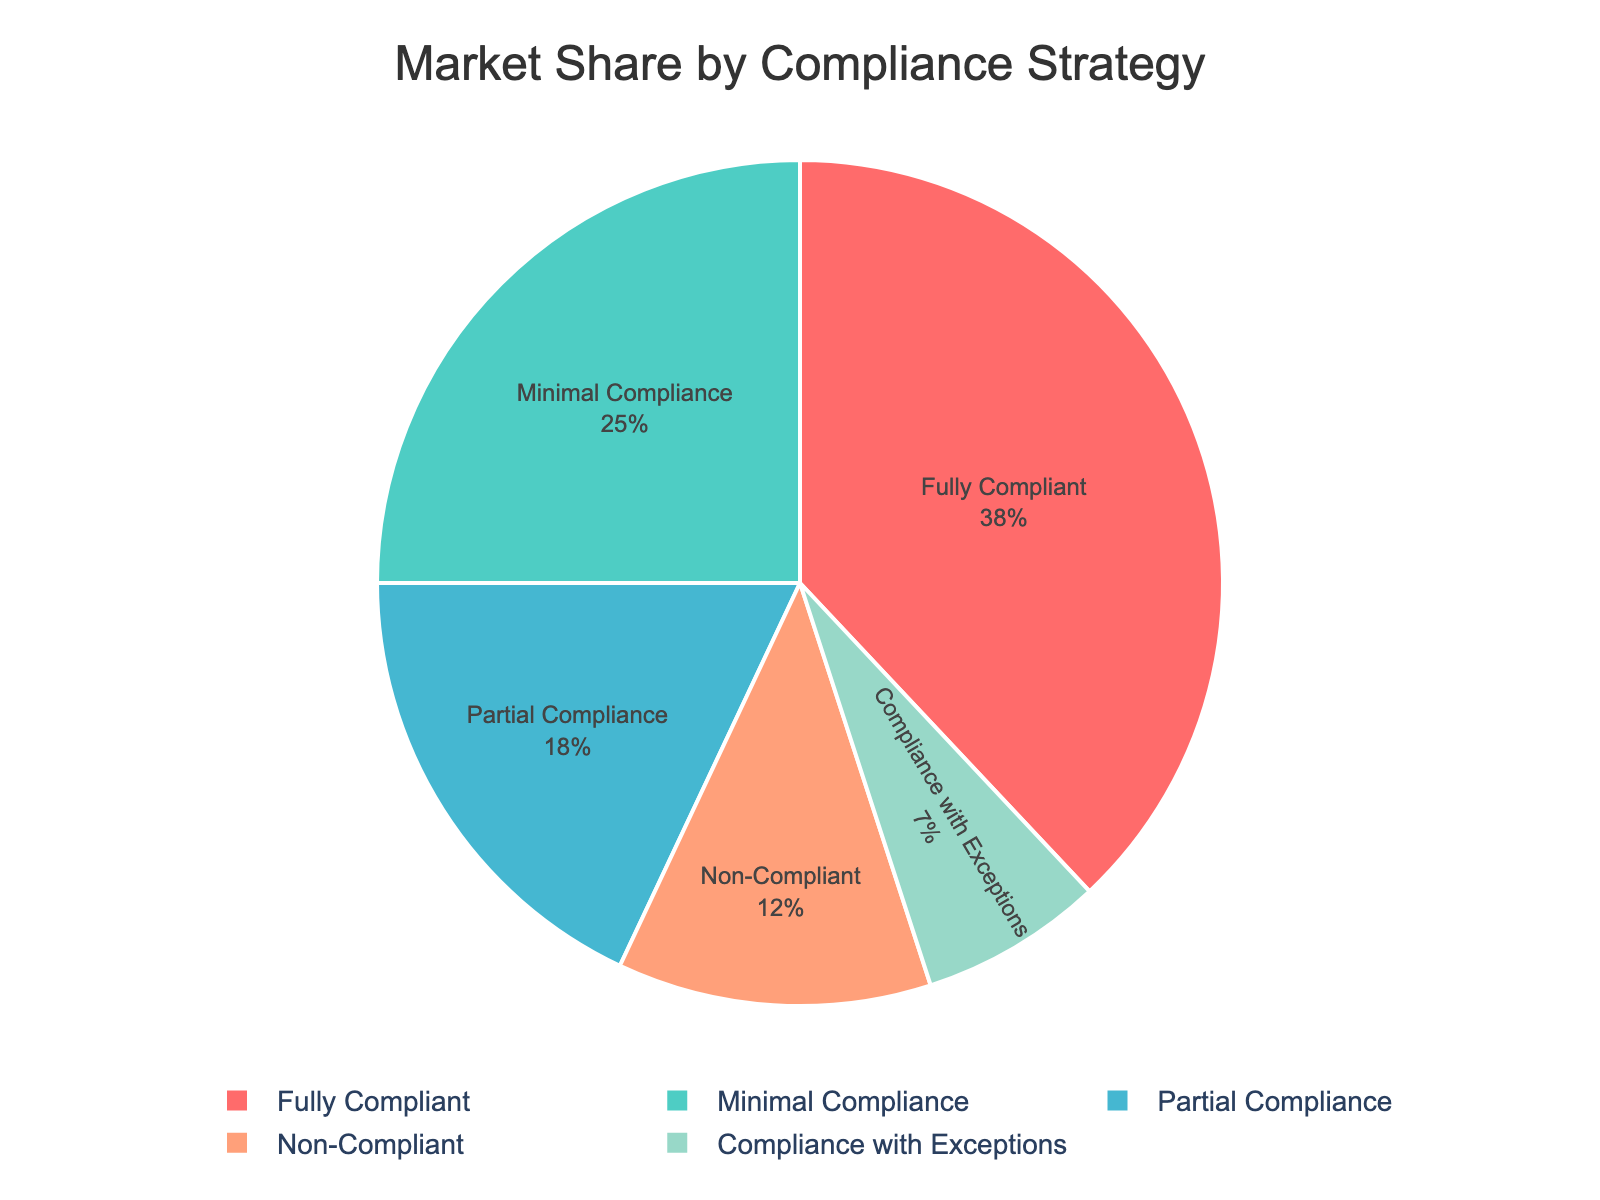What percentage of the market share is not fully compliant (i.e., minimal, non-compliant, partial, and compliance with exceptions)? To find the percentage of the market share that is not fully compliant, sum the market shares of minimal compliance (25%), non-compliant (12%), partial compliance (18%), and compliance with exceptions (7%). So, 25% + 12% + 18% + 7% = 62%.
Answer: 62% Which compliance strategy has the largest market share? Identify the segment with the highest percentage from the pie chart. The 'Fully Compliant' segment has the largest share at 38%.
Answer: Fully Compliant How does the market share of minimal compliance compare to that of partial compliance? Compare the percentages directly from the pie chart. Minimal compliance has 25%, and partial compliance has 18%. So, minimal compliance has a larger market share.
Answer: Minimal compliance is larger What is the total market share of fully compliant and partial compliance strategies combined? Sum the market shares of fully compliant (38%) and partial compliance (18%). Thus, 38% + 18% = 56%.
Answer: 56% Which compliance strategy has the smallest market share, and what is its percentage? Look for the smallest segment in the pie chart. The 'Compliance with Exceptions' strategy has the smallest share at 7%.
Answer: Compliance with Exceptions, 7% What is the ratio of the market share of fully compliant businesses to non-compliant businesses? Determine the percentages from the chart: fully compliant is 38%, and non-compliant is 12%. The ratio is 38/12, which simplifies to about 3.17.
Answer: 3.17 How many compliance strategies have a market share greater than 15%? Look at the pie chart and count the segments with percentages greater than 15%. The strategies are fully compliant (38%), minimal compliance (25%), and partial compliance (18%). There are three such strategies.
Answer: 3 What is the difference between the market shares of the fully compliant strategy and the minimal compliance strategy? Subtract the market share of minimal compliance (25%) from fully compliant (38%). So, 38% - 25% = 13%.
Answer: 13% Which compliance strategies collectively hold more than half of the market share? Identify and sum the strategies until the total is greater than 50%. Fully compliant (38%) and minimal compliance (25%) together sum to 63%, exceeding half of the market.
Answer: Fully compliant and minimal compliance 